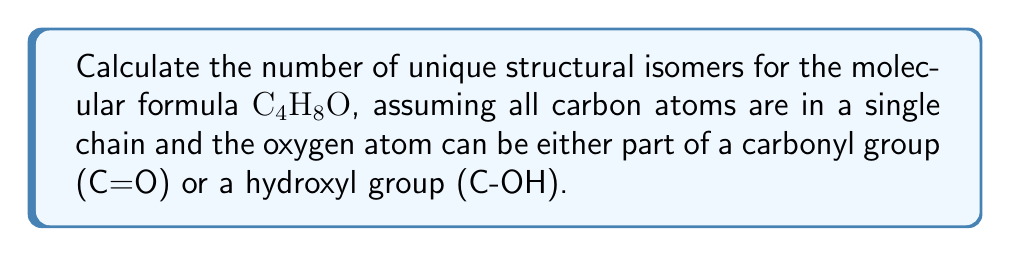Help me with this question. Let's approach this step-by-step:

1) First, we need to consider the possible positions of the oxygen atom:
   a) As a carbonyl group (C=O): It can be at the end of the chain or in the middle.
   b) As a hydroxyl group (C-OH): It can be attached to any of the 4 carbon atoms.

2) Carbonyl group possibilities:
   - At the end: 2 positions (1st or 4th carbon)
   - In the middle: 1 position (2nd or 3rd carbon, which are equivalent due to symmetry)
   Total carbonyl structures: $2 + 1 = 3$

3) Hydroxyl group possibilities:
   - Can be attached to any of the 4 carbon atoms
   Total hydroxyl structures: $4$

4) For each of these 7 basic structures, we need to consider the possible arrangements of the remaining hydrogen atoms.

5) For carbonyl structures:
   - End position: No additional isomers
   - Middle position: 2 isomers (depending on which side the longer alkyl group is on)

6) For hydroxyl structures:
   - 1st or 4th carbon: No additional isomers
   - 2nd or 3rd carbon: 2 isomers each (depending on which side the OH group is on)

7) Summing up all possibilities:
   $$\text{Total isomers} = (2 + 1 \times 2) + (2 + 2 \times 2) = 3 + 6 = 9$$

Therefore, there are 9 unique structural isomers for $C_4H_8O$ under the given conditions.
Answer: 9 